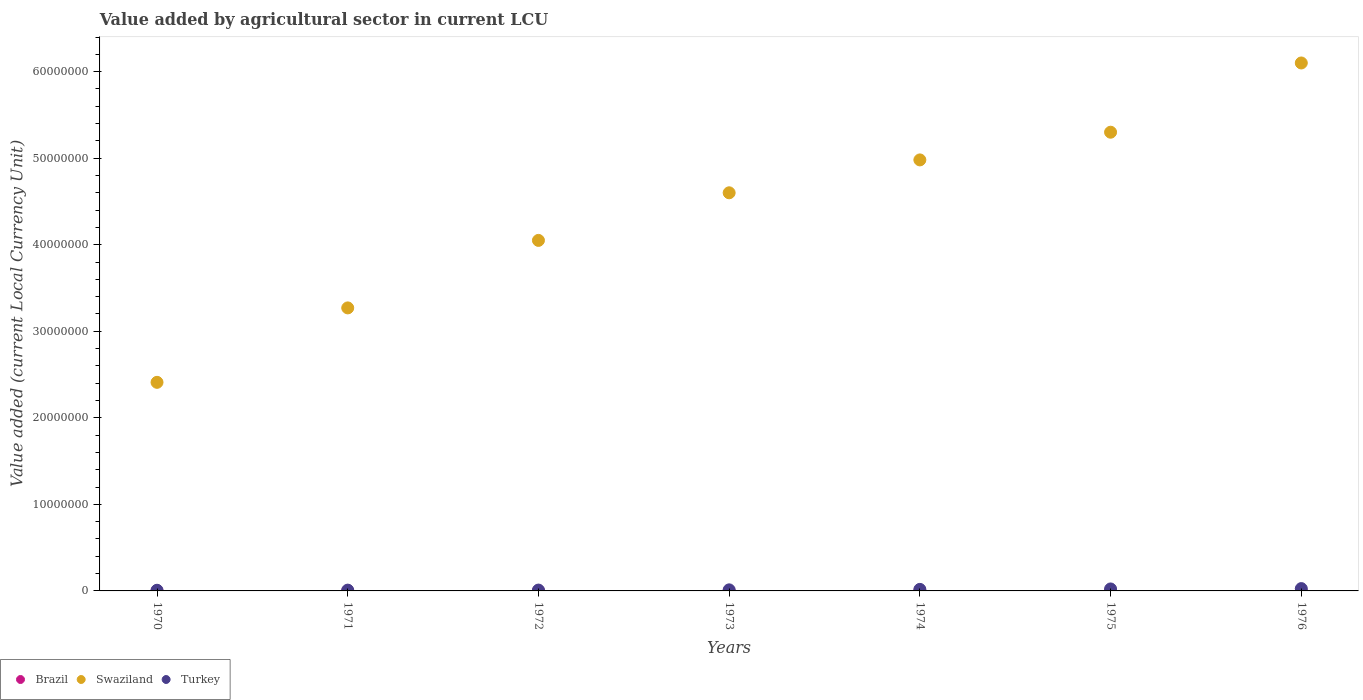Is the number of dotlines equal to the number of legend labels?
Your answer should be compact. Yes. What is the value added by agricultural sector in Swaziland in 1972?
Provide a short and direct response. 4.05e+07. Across all years, what is the maximum value added by agricultural sector in Brazil?
Offer a terse response. 0.07. Across all years, what is the minimum value added by agricultural sector in Turkey?
Give a very brief answer. 7.68e+04. In which year was the value added by agricultural sector in Swaziland maximum?
Your answer should be compact. 1976. What is the total value added by agricultural sector in Turkey in the graph?
Provide a succinct answer. 1.06e+06. What is the difference between the value added by agricultural sector in Brazil in 1971 and that in 1975?
Your answer should be compact. -0.03. What is the difference between the value added by agricultural sector in Turkey in 1972 and the value added by agricultural sector in Swaziland in 1974?
Your response must be concise. -4.97e+07. What is the average value added by agricultural sector in Brazil per year?
Provide a short and direct response. 0.03. In the year 1971, what is the difference between the value added by agricultural sector in Brazil and value added by agricultural sector in Turkey?
Your answer should be very brief. -9.06e+04. What is the ratio of the value added by agricultural sector in Swaziland in 1970 to that in 1972?
Offer a terse response. 0.6. Is the difference between the value added by agricultural sector in Brazil in 1970 and 1972 greater than the difference between the value added by agricultural sector in Turkey in 1970 and 1972?
Make the answer very short. Yes. What is the difference between the highest and the second highest value added by agricultural sector in Brazil?
Ensure brevity in your answer.  0.03. What is the difference between the highest and the lowest value added by agricultural sector in Swaziland?
Offer a terse response. 3.69e+07. Does the value added by agricultural sector in Brazil monotonically increase over the years?
Your response must be concise. Yes. Is the value added by agricultural sector in Swaziland strictly greater than the value added by agricultural sector in Turkey over the years?
Provide a succinct answer. Yes. How many dotlines are there?
Your response must be concise. 3. How many years are there in the graph?
Your response must be concise. 7. Are the values on the major ticks of Y-axis written in scientific E-notation?
Your answer should be very brief. No. Does the graph contain any zero values?
Offer a very short reply. No. How many legend labels are there?
Offer a very short reply. 3. How are the legend labels stacked?
Keep it short and to the point. Horizontal. What is the title of the graph?
Provide a short and direct response. Value added by agricultural sector in current LCU. What is the label or title of the X-axis?
Provide a short and direct response. Years. What is the label or title of the Y-axis?
Offer a terse response. Value added (current Local Currency Unit). What is the Value added (current Local Currency Unit) of Brazil in 1970?
Offer a terse response. 0.01. What is the Value added (current Local Currency Unit) of Swaziland in 1970?
Provide a succinct answer. 2.41e+07. What is the Value added (current Local Currency Unit) of Turkey in 1970?
Give a very brief answer. 7.68e+04. What is the Value added (current Local Currency Unit) of Brazil in 1971?
Provide a succinct answer. 0.01. What is the Value added (current Local Currency Unit) of Swaziland in 1971?
Your answer should be very brief. 3.27e+07. What is the Value added (current Local Currency Unit) in Turkey in 1971?
Provide a succinct answer. 9.06e+04. What is the Value added (current Local Currency Unit) in Brazil in 1972?
Keep it short and to the point. 0.01. What is the Value added (current Local Currency Unit) in Swaziland in 1972?
Make the answer very short. 4.05e+07. What is the Value added (current Local Currency Unit) in Turkey in 1972?
Provide a short and direct response. 9.92e+04. What is the Value added (current Local Currency Unit) in Brazil in 1973?
Your answer should be compact. 0.02. What is the Value added (current Local Currency Unit) of Swaziland in 1973?
Offer a very short reply. 4.60e+07. What is the Value added (current Local Currency Unit) of Turkey in 1973?
Your answer should be very brief. 1.24e+05. What is the Value added (current Local Currency Unit) in Brazil in 1974?
Offer a terse response. 0.03. What is the Value added (current Local Currency Unit) of Swaziland in 1974?
Your response must be concise. 4.98e+07. What is the Value added (current Local Currency Unit) in Turkey in 1974?
Offer a terse response. 1.78e+05. What is the Value added (current Local Currency Unit) of Brazil in 1975?
Provide a succinct answer. 0.04. What is the Value added (current Local Currency Unit) in Swaziland in 1975?
Your response must be concise. 5.30e+07. What is the Value added (current Local Currency Unit) of Turkey in 1975?
Your answer should be compact. 2.28e+05. What is the Value added (current Local Currency Unit) of Brazil in 1976?
Your answer should be very brief. 0.07. What is the Value added (current Local Currency Unit) of Swaziland in 1976?
Give a very brief answer. 6.10e+07. What is the Value added (current Local Currency Unit) of Turkey in 1976?
Give a very brief answer. 2.68e+05. Across all years, what is the maximum Value added (current Local Currency Unit) in Brazil?
Offer a very short reply. 0.07. Across all years, what is the maximum Value added (current Local Currency Unit) of Swaziland?
Give a very brief answer. 6.10e+07. Across all years, what is the maximum Value added (current Local Currency Unit) in Turkey?
Keep it short and to the point. 2.68e+05. Across all years, what is the minimum Value added (current Local Currency Unit) of Brazil?
Give a very brief answer. 0.01. Across all years, what is the minimum Value added (current Local Currency Unit) of Swaziland?
Ensure brevity in your answer.  2.41e+07. Across all years, what is the minimum Value added (current Local Currency Unit) in Turkey?
Your response must be concise. 7.68e+04. What is the total Value added (current Local Currency Unit) in Brazil in the graph?
Provide a succinct answer. 0.19. What is the total Value added (current Local Currency Unit) in Swaziland in the graph?
Provide a succinct answer. 3.07e+08. What is the total Value added (current Local Currency Unit) in Turkey in the graph?
Your response must be concise. 1.06e+06. What is the difference between the Value added (current Local Currency Unit) in Brazil in 1970 and that in 1971?
Your answer should be very brief. -0. What is the difference between the Value added (current Local Currency Unit) of Swaziland in 1970 and that in 1971?
Your answer should be compact. -8.60e+06. What is the difference between the Value added (current Local Currency Unit) in Turkey in 1970 and that in 1971?
Ensure brevity in your answer.  -1.38e+04. What is the difference between the Value added (current Local Currency Unit) in Brazil in 1970 and that in 1972?
Offer a very short reply. -0.01. What is the difference between the Value added (current Local Currency Unit) in Swaziland in 1970 and that in 1972?
Your answer should be very brief. -1.64e+07. What is the difference between the Value added (current Local Currency Unit) of Turkey in 1970 and that in 1972?
Your response must be concise. -2.24e+04. What is the difference between the Value added (current Local Currency Unit) in Brazil in 1970 and that in 1973?
Your answer should be compact. -0.01. What is the difference between the Value added (current Local Currency Unit) in Swaziland in 1970 and that in 1973?
Your response must be concise. -2.19e+07. What is the difference between the Value added (current Local Currency Unit) of Turkey in 1970 and that in 1973?
Your answer should be very brief. -4.68e+04. What is the difference between the Value added (current Local Currency Unit) of Brazil in 1970 and that in 1974?
Offer a very short reply. -0.02. What is the difference between the Value added (current Local Currency Unit) of Swaziland in 1970 and that in 1974?
Give a very brief answer. -2.57e+07. What is the difference between the Value added (current Local Currency Unit) of Turkey in 1970 and that in 1974?
Give a very brief answer. -1.02e+05. What is the difference between the Value added (current Local Currency Unit) of Brazil in 1970 and that in 1975?
Keep it short and to the point. -0.03. What is the difference between the Value added (current Local Currency Unit) in Swaziland in 1970 and that in 1975?
Give a very brief answer. -2.89e+07. What is the difference between the Value added (current Local Currency Unit) in Turkey in 1970 and that in 1975?
Provide a short and direct response. -1.51e+05. What is the difference between the Value added (current Local Currency Unit) in Brazil in 1970 and that in 1976?
Keep it short and to the point. -0.06. What is the difference between the Value added (current Local Currency Unit) in Swaziland in 1970 and that in 1976?
Keep it short and to the point. -3.69e+07. What is the difference between the Value added (current Local Currency Unit) in Turkey in 1970 and that in 1976?
Provide a succinct answer. -1.91e+05. What is the difference between the Value added (current Local Currency Unit) in Brazil in 1971 and that in 1972?
Provide a succinct answer. -0. What is the difference between the Value added (current Local Currency Unit) of Swaziland in 1971 and that in 1972?
Make the answer very short. -7.80e+06. What is the difference between the Value added (current Local Currency Unit) of Turkey in 1971 and that in 1972?
Offer a very short reply. -8600. What is the difference between the Value added (current Local Currency Unit) of Brazil in 1971 and that in 1973?
Offer a very short reply. -0.01. What is the difference between the Value added (current Local Currency Unit) of Swaziland in 1971 and that in 1973?
Your answer should be compact. -1.33e+07. What is the difference between the Value added (current Local Currency Unit) of Turkey in 1971 and that in 1973?
Your answer should be compact. -3.30e+04. What is the difference between the Value added (current Local Currency Unit) in Brazil in 1971 and that in 1974?
Make the answer very short. -0.02. What is the difference between the Value added (current Local Currency Unit) of Swaziland in 1971 and that in 1974?
Make the answer very short. -1.71e+07. What is the difference between the Value added (current Local Currency Unit) of Turkey in 1971 and that in 1974?
Offer a very short reply. -8.79e+04. What is the difference between the Value added (current Local Currency Unit) of Brazil in 1971 and that in 1975?
Your answer should be very brief. -0.03. What is the difference between the Value added (current Local Currency Unit) of Swaziland in 1971 and that in 1975?
Your answer should be very brief. -2.03e+07. What is the difference between the Value added (current Local Currency Unit) in Turkey in 1971 and that in 1975?
Keep it short and to the point. -1.37e+05. What is the difference between the Value added (current Local Currency Unit) in Brazil in 1971 and that in 1976?
Offer a terse response. -0.06. What is the difference between the Value added (current Local Currency Unit) in Swaziland in 1971 and that in 1976?
Your response must be concise. -2.83e+07. What is the difference between the Value added (current Local Currency Unit) of Turkey in 1971 and that in 1976?
Your answer should be very brief. -1.77e+05. What is the difference between the Value added (current Local Currency Unit) in Brazil in 1972 and that in 1973?
Your response must be concise. -0.01. What is the difference between the Value added (current Local Currency Unit) of Swaziland in 1972 and that in 1973?
Give a very brief answer. -5.50e+06. What is the difference between the Value added (current Local Currency Unit) of Turkey in 1972 and that in 1973?
Offer a terse response. -2.44e+04. What is the difference between the Value added (current Local Currency Unit) of Brazil in 1972 and that in 1974?
Keep it short and to the point. -0.02. What is the difference between the Value added (current Local Currency Unit) of Swaziland in 1972 and that in 1974?
Offer a very short reply. -9.30e+06. What is the difference between the Value added (current Local Currency Unit) in Turkey in 1972 and that in 1974?
Your answer should be very brief. -7.93e+04. What is the difference between the Value added (current Local Currency Unit) of Brazil in 1972 and that in 1975?
Keep it short and to the point. -0.03. What is the difference between the Value added (current Local Currency Unit) in Swaziland in 1972 and that in 1975?
Give a very brief answer. -1.25e+07. What is the difference between the Value added (current Local Currency Unit) in Turkey in 1972 and that in 1975?
Offer a very short reply. -1.29e+05. What is the difference between the Value added (current Local Currency Unit) of Brazil in 1972 and that in 1976?
Your response must be concise. -0.05. What is the difference between the Value added (current Local Currency Unit) in Swaziland in 1972 and that in 1976?
Your answer should be very brief. -2.05e+07. What is the difference between the Value added (current Local Currency Unit) of Turkey in 1972 and that in 1976?
Offer a very short reply. -1.68e+05. What is the difference between the Value added (current Local Currency Unit) in Brazil in 1973 and that in 1974?
Offer a very short reply. -0.01. What is the difference between the Value added (current Local Currency Unit) of Swaziland in 1973 and that in 1974?
Make the answer very short. -3.80e+06. What is the difference between the Value added (current Local Currency Unit) in Turkey in 1973 and that in 1974?
Your answer should be compact. -5.49e+04. What is the difference between the Value added (current Local Currency Unit) in Brazil in 1973 and that in 1975?
Provide a short and direct response. -0.02. What is the difference between the Value added (current Local Currency Unit) of Swaziland in 1973 and that in 1975?
Keep it short and to the point. -7.00e+06. What is the difference between the Value added (current Local Currency Unit) in Turkey in 1973 and that in 1975?
Ensure brevity in your answer.  -1.04e+05. What is the difference between the Value added (current Local Currency Unit) of Brazil in 1973 and that in 1976?
Provide a succinct answer. -0.05. What is the difference between the Value added (current Local Currency Unit) in Swaziland in 1973 and that in 1976?
Offer a very short reply. -1.50e+07. What is the difference between the Value added (current Local Currency Unit) in Turkey in 1973 and that in 1976?
Provide a short and direct response. -1.44e+05. What is the difference between the Value added (current Local Currency Unit) in Brazil in 1974 and that in 1975?
Provide a succinct answer. -0.01. What is the difference between the Value added (current Local Currency Unit) of Swaziland in 1974 and that in 1975?
Offer a terse response. -3.20e+06. What is the difference between the Value added (current Local Currency Unit) of Turkey in 1974 and that in 1975?
Your answer should be very brief. -4.95e+04. What is the difference between the Value added (current Local Currency Unit) of Brazil in 1974 and that in 1976?
Give a very brief answer. -0.04. What is the difference between the Value added (current Local Currency Unit) in Swaziland in 1974 and that in 1976?
Your answer should be compact. -1.12e+07. What is the difference between the Value added (current Local Currency Unit) of Turkey in 1974 and that in 1976?
Your answer should be compact. -8.92e+04. What is the difference between the Value added (current Local Currency Unit) of Brazil in 1975 and that in 1976?
Offer a terse response. -0.03. What is the difference between the Value added (current Local Currency Unit) in Swaziland in 1975 and that in 1976?
Your response must be concise. -8.00e+06. What is the difference between the Value added (current Local Currency Unit) of Turkey in 1975 and that in 1976?
Your response must be concise. -3.97e+04. What is the difference between the Value added (current Local Currency Unit) in Brazil in 1970 and the Value added (current Local Currency Unit) in Swaziland in 1971?
Offer a very short reply. -3.27e+07. What is the difference between the Value added (current Local Currency Unit) of Brazil in 1970 and the Value added (current Local Currency Unit) of Turkey in 1971?
Give a very brief answer. -9.06e+04. What is the difference between the Value added (current Local Currency Unit) of Swaziland in 1970 and the Value added (current Local Currency Unit) of Turkey in 1971?
Offer a terse response. 2.40e+07. What is the difference between the Value added (current Local Currency Unit) of Brazil in 1970 and the Value added (current Local Currency Unit) of Swaziland in 1972?
Keep it short and to the point. -4.05e+07. What is the difference between the Value added (current Local Currency Unit) in Brazil in 1970 and the Value added (current Local Currency Unit) in Turkey in 1972?
Your answer should be very brief. -9.92e+04. What is the difference between the Value added (current Local Currency Unit) of Swaziland in 1970 and the Value added (current Local Currency Unit) of Turkey in 1972?
Offer a very short reply. 2.40e+07. What is the difference between the Value added (current Local Currency Unit) of Brazil in 1970 and the Value added (current Local Currency Unit) of Swaziland in 1973?
Your answer should be compact. -4.60e+07. What is the difference between the Value added (current Local Currency Unit) of Brazil in 1970 and the Value added (current Local Currency Unit) of Turkey in 1973?
Your answer should be very brief. -1.24e+05. What is the difference between the Value added (current Local Currency Unit) of Swaziland in 1970 and the Value added (current Local Currency Unit) of Turkey in 1973?
Provide a succinct answer. 2.40e+07. What is the difference between the Value added (current Local Currency Unit) in Brazil in 1970 and the Value added (current Local Currency Unit) in Swaziland in 1974?
Ensure brevity in your answer.  -4.98e+07. What is the difference between the Value added (current Local Currency Unit) in Brazil in 1970 and the Value added (current Local Currency Unit) in Turkey in 1974?
Offer a very short reply. -1.78e+05. What is the difference between the Value added (current Local Currency Unit) of Swaziland in 1970 and the Value added (current Local Currency Unit) of Turkey in 1974?
Keep it short and to the point. 2.39e+07. What is the difference between the Value added (current Local Currency Unit) of Brazil in 1970 and the Value added (current Local Currency Unit) of Swaziland in 1975?
Provide a succinct answer. -5.30e+07. What is the difference between the Value added (current Local Currency Unit) in Brazil in 1970 and the Value added (current Local Currency Unit) in Turkey in 1975?
Provide a short and direct response. -2.28e+05. What is the difference between the Value added (current Local Currency Unit) of Swaziland in 1970 and the Value added (current Local Currency Unit) of Turkey in 1975?
Your answer should be compact. 2.39e+07. What is the difference between the Value added (current Local Currency Unit) of Brazil in 1970 and the Value added (current Local Currency Unit) of Swaziland in 1976?
Provide a short and direct response. -6.10e+07. What is the difference between the Value added (current Local Currency Unit) in Brazil in 1970 and the Value added (current Local Currency Unit) in Turkey in 1976?
Keep it short and to the point. -2.68e+05. What is the difference between the Value added (current Local Currency Unit) in Swaziland in 1970 and the Value added (current Local Currency Unit) in Turkey in 1976?
Provide a succinct answer. 2.38e+07. What is the difference between the Value added (current Local Currency Unit) in Brazil in 1971 and the Value added (current Local Currency Unit) in Swaziland in 1972?
Provide a succinct answer. -4.05e+07. What is the difference between the Value added (current Local Currency Unit) of Brazil in 1971 and the Value added (current Local Currency Unit) of Turkey in 1972?
Your answer should be very brief. -9.92e+04. What is the difference between the Value added (current Local Currency Unit) of Swaziland in 1971 and the Value added (current Local Currency Unit) of Turkey in 1972?
Provide a succinct answer. 3.26e+07. What is the difference between the Value added (current Local Currency Unit) in Brazil in 1971 and the Value added (current Local Currency Unit) in Swaziland in 1973?
Your answer should be compact. -4.60e+07. What is the difference between the Value added (current Local Currency Unit) in Brazil in 1971 and the Value added (current Local Currency Unit) in Turkey in 1973?
Ensure brevity in your answer.  -1.24e+05. What is the difference between the Value added (current Local Currency Unit) of Swaziland in 1971 and the Value added (current Local Currency Unit) of Turkey in 1973?
Make the answer very short. 3.26e+07. What is the difference between the Value added (current Local Currency Unit) in Brazil in 1971 and the Value added (current Local Currency Unit) in Swaziland in 1974?
Offer a very short reply. -4.98e+07. What is the difference between the Value added (current Local Currency Unit) in Brazil in 1971 and the Value added (current Local Currency Unit) in Turkey in 1974?
Provide a short and direct response. -1.78e+05. What is the difference between the Value added (current Local Currency Unit) of Swaziland in 1971 and the Value added (current Local Currency Unit) of Turkey in 1974?
Keep it short and to the point. 3.25e+07. What is the difference between the Value added (current Local Currency Unit) of Brazil in 1971 and the Value added (current Local Currency Unit) of Swaziland in 1975?
Offer a very short reply. -5.30e+07. What is the difference between the Value added (current Local Currency Unit) of Brazil in 1971 and the Value added (current Local Currency Unit) of Turkey in 1975?
Your answer should be very brief. -2.28e+05. What is the difference between the Value added (current Local Currency Unit) of Swaziland in 1971 and the Value added (current Local Currency Unit) of Turkey in 1975?
Provide a short and direct response. 3.25e+07. What is the difference between the Value added (current Local Currency Unit) of Brazil in 1971 and the Value added (current Local Currency Unit) of Swaziland in 1976?
Give a very brief answer. -6.10e+07. What is the difference between the Value added (current Local Currency Unit) of Brazil in 1971 and the Value added (current Local Currency Unit) of Turkey in 1976?
Offer a very short reply. -2.68e+05. What is the difference between the Value added (current Local Currency Unit) in Swaziland in 1971 and the Value added (current Local Currency Unit) in Turkey in 1976?
Provide a short and direct response. 3.24e+07. What is the difference between the Value added (current Local Currency Unit) in Brazil in 1972 and the Value added (current Local Currency Unit) in Swaziland in 1973?
Make the answer very short. -4.60e+07. What is the difference between the Value added (current Local Currency Unit) of Brazil in 1972 and the Value added (current Local Currency Unit) of Turkey in 1973?
Your answer should be very brief. -1.24e+05. What is the difference between the Value added (current Local Currency Unit) of Swaziland in 1972 and the Value added (current Local Currency Unit) of Turkey in 1973?
Provide a succinct answer. 4.04e+07. What is the difference between the Value added (current Local Currency Unit) in Brazil in 1972 and the Value added (current Local Currency Unit) in Swaziland in 1974?
Provide a succinct answer. -4.98e+07. What is the difference between the Value added (current Local Currency Unit) of Brazil in 1972 and the Value added (current Local Currency Unit) of Turkey in 1974?
Provide a short and direct response. -1.78e+05. What is the difference between the Value added (current Local Currency Unit) of Swaziland in 1972 and the Value added (current Local Currency Unit) of Turkey in 1974?
Give a very brief answer. 4.03e+07. What is the difference between the Value added (current Local Currency Unit) of Brazil in 1972 and the Value added (current Local Currency Unit) of Swaziland in 1975?
Your response must be concise. -5.30e+07. What is the difference between the Value added (current Local Currency Unit) in Brazil in 1972 and the Value added (current Local Currency Unit) in Turkey in 1975?
Give a very brief answer. -2.28e+05. What is the difference between the Value added (current Local Currency Unit) in Swaziland in 1972 and the Value added (current Local Currency Unit) in Turkey in 1975?
Offer a terse response. 4.03e+07. What is the difference between the Value added (current Local Currency Unit) in Brazil in 1972 and the Value added (current Local Currency Unit) in Swaziland in 1976?
Offer a terse response. -6.10e+07. What is the difference between the Value added (current Local Currency Unit) of Brazil in 1972 and the Value added (current Local Currency Unit) of Turkey in 1976?
Keep it short and to the point. -2.68e+05. What is the difference between the Value added (current Local Currency Unit) in Swaziland in 1972 and the Value added (current Local Currency Unit) in Turkey in 1976?
Your answer should be compact. 4.02e+07. What is the difference between the Value added (current Local Currency Unit) in Brazil in 1973 and the Value added (current Local Currency Unit) in Swaziland in 1974?
Provide a short and direct response. -4.98e+07. What is the difference between the Value added (current Local Currency Unit) of Brazil in 1973 and the Value added (current Local Currency Unit) of Turkey in 1974?
Make the answer very short. -1.78e+05. What is the difference between the Value added (current Local Currency Unit) in Swaziland in 1973 and the Value added (current Local Currency Unit) in Turkey in 1974?
Offer a terse response. 4.58e+07. What is the difference between the Value added (current Local Currency Unit) of Brazil in 1973 and the Value added (current Local Currency Unit) of Swaziland in 1975?
Provide a succinct answer. -5.30e+07. What is the difference between the Value added (current Local Currency Unit) in Brazil in 1973 and the Value added (current Local Currency Unit) in Turkey in 1975?
Give a very brief answer. -2.28e+05. What is the difference between the Value added (current Local Currency Unit) of Swaziland in 1973 and the Value added (current Local Currency Unit) of Turkey in 1975?
Provide a succinct answer. 4.58e+07. What is the difference between the Value added (current Local Currency Unit) in Brazil in 1973 and the Value added (current Local Currency Unit) in Swaziland in 1976?
Your response must be concise. -6.10e+07. What is the difference between the Value added (current Local Currency Unit) of Brazil in 1973 and the Value added (current Local Currency Unit) of Turkey in 1976?
Provide a succinct answer. -2.68e+05. What is the difference between the Value added (current Local Currency Unit) in Swaziland in 1973 and the Value added (current Local Currency Unit) in Turkey in 1976?
Give a very brief answer. 4.57e+07. What is the difference between the Value added (current Local Currency Unit) in Brazil in 1974 and the Value added (current Local Currency Unit) in Swaziland in 1975?
Give a very brief answer. -5.30e+07. What is the difference between the Value added (current Local Currency Unit) in Brazil in 1974 and the Value added (current Local Currency Unit) in Turkey in 1975?
Provide a short and direct response. -2.28e+05. What is the difference between the Value added (current Local Currency Unit) of Swaziland in 1974 and the Value added (current Local Currency Unit) of Turkey in 1975?
Your answer should be compact. 4.96e+07. What is the difference between the Value added (current Local Currency Unit) of Brazil in 1974 and the Value added (current Local Currency Unit) of Swaziland in 1976?
Provide a succinct answer. -6.10e+07. What is the difference between the Value added (current Local Currency Unit) in Brazil in 1974 and the Value added (current Local Currency Unit) in Turkey in 1976?
Keep it short and to the point. -2.68e+05. What is the difference between the Value added (current Local Currency Unit) of Swaziland in 1974 and the Value added (current Local Currency Unit) of Turkey in 1976?
Keep it short and to the point. 4.95e+07. What is the difference between the Value added (current Local Currency Unit) in Brazil in 1975 and the Value added (current Local Currency Unit) in Swaziland in 1976?
Your answer should be compact. -6.10e+07. What is the difference between the Value added (current Local Currency Unit) of Brazil in 1975 and the Value added (current Local Currency Unit) of Turkey in 1976?
Provide a succinct answer. -2.68e+05. What is the difference between the Value added (current Local Currency Unit) in Swaziland in 1975 and the Value added (current Local Currency Unit) in Turkey in 1976?
Your answer should be very brief. 5.27e+07. What is the average Value added (current Local Currency Unit) of Brazil per year?
Your answer should be compact. 0.03. What is the average Value added (current Local Currency Unit) of Swaziland per year?
Make the answer very short. 4.39e+07. What is the average Value added (current Local Currency Unit) in Turkey per year?
Provide a short and direct response. 1.52e+05. In the year 1970, what is the difference between the Value added (current Local Currency Unit) in Brazil and Value added (current Local Currency Unit) in Swaziland?
Provide a short and direct response. -2.41e+07. In the year 1970, what is the difference between the Value added (current Local Currency Unit) of Brazil and Value added (current Local Currency Unit) of Turkey?
Your answer should be very brief. -7.68e+04. In the year 1970, what is the difference between the Value added (current Local Currency Unit) of Swaziland and Value added (current Local Currency Unit) of Turkey?
Offer a very short reply. 2.40e+07. In the year 1971, what is the difference between the Value added (current Local Currency Unit) of Brazil and Value added (current Local Currency Unit) of Swaziland?
Your answer should be compact. -3.27e+07. In the year 1971, what is the difference between the Value added (current Local Currency Unit) of Brazil and Value added (current Local Currency Unit) of Turkey?
Keep it short and to the point. -9.06e+04. In the year 1971, what is the difference between the Value added (current Local Currency Unit) in Swaziland and Value added (current Local Currency Unit) in Turkey?
Your answer should be very brief. 3.26e+07. In the year 1972, what is the difference between the Value added (current Local Currency Unit) of Brazil and Value added (current Local Currency Unit) of Swaziland?
Your answer should be very brief. -4.05e+07. In the year 1972, what is the difference between the Value added (current Local Currency Unit) in Brazil and Value added (current Local Currency Unit) in Turkey?
Provide a succinct answer. -9.92e+04. In the year 1972, what is the difference between the Value added (current Local Currency Unit) in Swaziland and Value added (current Local Currency Unit) in Turkey?
Ensure brevity in your answer.  4.04e+07. In the year 1973, what is the difference between the Value added (current Local Currency Unit) in Brazil and Value added (current Local Currency Unit) in Swaziland?
Provide a short and direct response. -4.60e+07. In the year 1973, what is the difference between the Value added (current Local Currency Unit) of Brazil and Value added (current Local Currency Unit) of Turkey?
Ensure brevity in your answer.  -1.24e+05. In the year 1973, what is the difference between the Value added (current Local Currency Unit) in Swaziland and Value added (current Local Currency Unit) in Turkey?
Give a very brief answer. 4.59e+07. In the year 1974, what is the difference between the Value added (current Local Currency Unit) of Brazil and Value added (current Local Currency Unit) of Swaziland?
Provide a short and direct response. -4.98e+07. In the year 1974, what is the difference between the Value added (current Local Currency Unit) in Brazil and Value added (current Local Currency Unit) in Turkey?
Keep it short and to the point. -1.78e+05. In the year 1974, what is the difference between the Value added (current Local Currency Unit) of Swaziland and Value added (current Local Currency Unit) of Turkey?
Your response must be concise. 4.96e+07. In the year 1975, what is the difference between the Value added (current Local Currency Unit) in Brazil and Value added (current Local Currency Unit) in Swaziland?
Keep it short and to the point. -5.30e+07. In the year 1975, what is the difference between the Value added (current Local Currency Unit) in Brazil and Value added (current Local Currency Unit) in Turkey?
Your answer should be very brief. -2.28e+05. In the year 1975, what is the difference between the Value added (current Local Currency Unit) of Swaziland and Value added (current Local Currency Unit) of Turkey?
Your answer should be compact. 5.28e+07. In the year 1976, what is the difference between the Value added (current Local Currency Unit) in Brazil and Value added (current Local Currency Unit) in Swaziland?
Make the answer very short. -6.10e+07. In the year 1976, what is the difference between the Value added (current Local Currency Unit) of Brazil and Value added (current Local Currency Unit) of Turkey?
Keep it short and to the point. -2.68e+05. In the year 1976, what is the difference between the Value added (current Local Currency Unit) of Swaziland and Value added (current Local Currency Unit) of Turkey?
Keep it short and to the point. 6.07e+07. What is the ratio of the Value added (current Local Currency Unit) of Brazil in 1970 to that in 1971?
Make the answer very short. 0.7. What is the ratio of the Value added (current Local Currency Unit) of Swaziland in 1970 to that in 1971?
Your response must be concise. 0.74. What is the ratio of the Value added (current Local Currency Unit) in Turkey in 1970 to that in 1971?
Give a very brief answer. 0.85. What is the ratio of the Value added (current Local Currency Unit) of Brazil in 1970 to that in 1972?
Give a very brief answer. 0.52. What is the ratio of the Value added (current Local Currency Unit) in Swaziland in 1970 to that in 1972?
Provide a succinct answer. 0.6. What is the ratio of the Value added (current Local Currency Unit) of Turkey in 1970 to that in 1972?
Ensure brevity in your answer.  0.77. What is the ratio of the Value added (current Local Currency Unit) in Brazil in 1970 to that in 1973?
Provide a succinct answer. 0.36. What is the ratio of the Value added (current Local Currency Unit) of Swaziland in 1970 to that in 1973?
Make the answer very short. 0.52. What is the ratio of the Value added (current Local Currency Unit) in Turkey in 1970 to that in 1973?
Ensure brevity in your answer.  0.62. What is the ratio of the Value added (current Local Currency Unit) of Brazil in 1970 to that in 1974?
Keep it short and to the point. 0.25. What is the ratio of the Value added (current Local Currency Unit) in Swaziland in 1970 to that in 1974?
Your answer should be very brief. 0.48. What is the ratio of the Value added (current Local Currency Unit) of Turkey in 1970 to that in 1974?
Your response must be concise. 0.43. What is the ratio of the Value added (current Local Currency Unit) of Brazil in 1970 to that in 1975?
Offer a terse response. 0.19. What is the ratio of the Value added (current Local Currency Unit) in Swaziland in 1970 to that in 1975?
Offer a terse response. 0.45. What is the ratio of the Value added (current Local Currency Unit) in Turkey in 1970 to that in 1975?
Your answer should be compact. 0.34. What is the ratio of the Value added (current Local Currency Unit) of Brazil in 1970 to that in 1976?
Offer a very short reply. 0.11. What is the ratio of the Value added (current Local Currency Unit) of Swaziland in 1970 to that in 1976?
Provide a short and direct response. 0.4. What is the ratio of the Value added (current Local Currency Unit) in Turkey in 1970 to that in 1976?
Make the answer very short. 0.29. What is the ratio of the Value added (current Local Currency Unit) in Brazil in 1971 to that in 1972?
Your response must be concise. 0.75. What is the ratio of the Value added (current Local Currency Unit) of Swaziland in 1971 to that in 1972?
Offer a terse response. 0.81. What is the ratio of the Value added (current Local Currency Unit) in Turkey in 1971 to that in 1972?
Your response must be concise. 0.91. What is the ratio of the Value added (current Local Currency Unit) in Brazil in 1971 to that in 1973?
Your answer should be compact. 0.52. What is the ratio of the Value added (current Local Currency Unit) in Swaziland in 1971 to that in 1973?
Offer a terse response. 0.71. What is the ratio of the Value added (current Local Currency Unit) in Turkey in 1971 to that in 1973?
Your response must be concise. 0.73. What is the ratio of the Value added (current Local Currency Unit) of Brazil in 1971 to that in 1974?
Your response must be concise. 0.36. What is the ratio of the Value added (current Local Currency Unit) in Swaziland in 1971 to that in 1974?
Give a very brief answer. 0.66. What is the ratio of the Value added (current Local Currency Unit) in Turkey in 1971 to that in 1974?
Keep it short and to the point. 0.51. What is the ratio of the Value added (current Local Currency Unit) of Brazil in 1971 to that in 1975?
Offer a terse response. 0.27. What is the ratio of the Value added (current Local Currency Unit) in Swaziland in 1971 to that in 1975?
Ensure brevity in your answer.  0.62. What is the ratio of the Value added (current Local Currency Unit) in Turkey in 1971 to that in 1975?
Your answer should be very brief. 0.4. What is the ratio of the Value added (current Local Currency Unit) in Brazil in 1971 to that in 1976?
Provide a short and direct response. 0.15. What is the ratio of the Value added (current Local Currency Unit) in Swaziland in 1971 to that in 1976?
Provide a short and direct response. 0.54. What is the ratio of the Value added (current Local Currency Unit) of Turkey in 1971 to that in 1976?
Provide a short and direct response. 0.34. What is the ratio of the Value added (current Local Currency Unit) in Brazil in 1972 to that in 1973?
Provide a short and direct response. 0.69. What is the ratio of the Value added (current Local Currency Unit) of Swaziland in 1972 to that in 1973?
Your answer should be very brief. 0.88. What is the ratio of the Value added (current Local Currency Unit) of Turkey in 1972 to that in 1973?
Your response must be concise. 0.8. What is the ratio of the Value added (current Local Currency Unit) of Brazil in 1972 to that in 1974?
Provide a succinct answer. 0.48. What is the ratio of the Value added (current Local Currency Unit) in Swaziland in 1972 to that in 1974?
Ensure brevity in your answer.  0.81. What is the ratio of the Value added (current Local Currency Unit) of Turkey in 1972 to that in 1974?
Your answer should be compact. 0.56. What is the ratio of the Value added (current Local Currency Unit) in Brazil in 1972 to that in 1975?
Your answer should be compact. 0.36. What is the ratio of the Value added (current Local Currency Unit) of Swaziland in 1972 to that in 1975?
Make the answer very short. 0.76. What is the ratio of the Value added (current Local Currency Unit) of Turkey in 1972 to that in 1975?
Your answer should be compact. 0.44. What is the ratio of the Value added (current Local Currency Unit) in Brazil in 1972 to that in 1976?
Ensure brevity in your answer.  0.21. What is the ratio of the Value added (current Local Currency Unit) in Swaziland in 1972 to that in 1976?
Ensure brevity in your answer.  0.66. What is the ratio of the Value added (current Local Currency Unit) of Turkey in 1972 to that in 1976?
Make the answer very short. 0.37. What is the ratio of the Value added (current Local Currency Unit) in Brazil in 1973 to that in 1974?
Your response must be concise. 0.69. What is the ratio of the Value added (current Local Currency Unit) of Swaziland in 1973 to that in 1974?
Offer a very short reply. 0.92. What is the ratio of the Value added (current Local Currency Unit) of Turkey in 1973 to that in 1974?
Provide a short and direct response. 0.69. What is the ratio of the Value added (current Local Currency Unit) of Brazil in 1973 to that in 1975?
Ensure brevity in your answer.  0.52. What is the ratio of the Value added (current Local Currency Unit) in Swaziland in 1973 to that in 1975?
Keep it short and to the point. 0.87. What is the ratio of the Value added (current Local Currency Unit) of Turkey in 1973 to that in 1975?
Make the answer very short. 0.54. What is the ratio of the Value added (current Local Currency Unit) in Brazil in 1973 to that in 1976?
Give a very brief answer. 0.3. What is the ratio of the Value added (current Local Currency Unit) of Swaziland in 1973 to that in 1976?
Give a very brief answer. 0.75. What is the ratio of the Value added (current Local Currency Unit) in Turkey in 1973 to that in 1976?
Your response must be concise. 0.46. What is the ratio of the Value added (current Local Currency Unit) of Brazil in 1974 to that in 1975?
Offer a very short reply. 0.75. What is the ratio of the Value added (current Local Currency Unit) of Swaziland in 1974 to that in 1975?
Make the answer very short. 0.94. What is the ratio of the Value added (current Local Currency Unit) in Turkey in 1974 to that in 1975?
Make the answer very short. 0.78. What is the ratio of the Value added (current Local Currency Unit) of Brazil in 1974 to that in 1976?
Your answer should be compact. 0.43. What is the ratio of the Value added (current Local Currency Unit) in Swaziland in 1974 to that in 1976?
Your response must be concise. 0.82. What is the ratio of the Value added (current Local Currency Unit) of Turkey in 1974 to that in 1976?
Provide a succinct answer. 0.67. What is the ratio of the Value added (current Local Currency Unit) in Brazil in 1975 to that in 1976?
Make the answer very short. 0.58. What is the ratio of the Value added (current Local Currency Unit) of Swaziland in 1975 to that in 1976?
Offer a very short reply. 0.87. What is the ratio of the Value added (current Local Currency Unit) in Turkey in 1975 to that in 1976?
Make the answer very short. 0.85. What is the difference between the highest and the second highest Value added (current Local Currency Unit) in Brazil?
Your response must be concise. 0.03. What is the difference between the highest and the second highest Value added (current Local Currency Unit) in Turkey?
Provide a succinct answer. 3.97e+04. What is the difference between the highest and the lowest Value added (current Local Currency Unit) in Brazil?
Your response must be concise. 0.06. What is the difference between the highest and the lowest Value added (current Local Currency Unit) in Swaziland?
Make the answer very short. 3.69e+07. What is the difference between the highest and the lowest Value added (current Local Currency Unit) of Turkey?
Provide a succinct answer. 1.91e+05. 